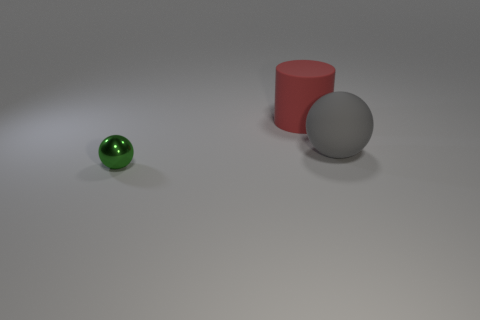How big is the thing in front of the big matte object that is in front of the red matte cylinder? small 